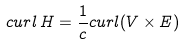<formula> <loc_0><loc_0><loc_500><loc_500>c u r l \, { H } = \frac { 1 } { c } c u r l ( { V } \times { E } )</formula> 